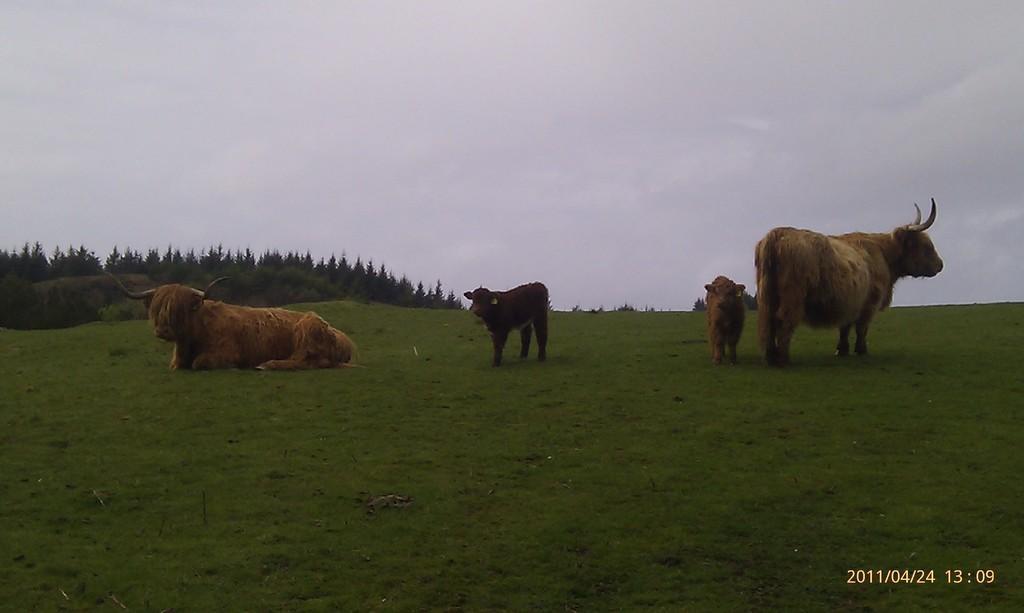In one or two sentences, can you explain what this image depicts? In this image in the front there's grass on the ground. In the center there are animals. In the background there are trees and the sky is cloudy and there are some numbers written on the bottom right of the image. 